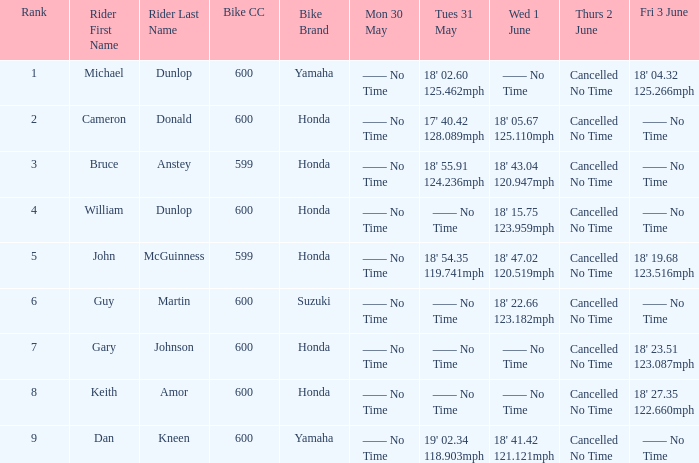What is the number of riders that had a Tues 31 May time of 18' 55.91 124.236mph? 1.0. 